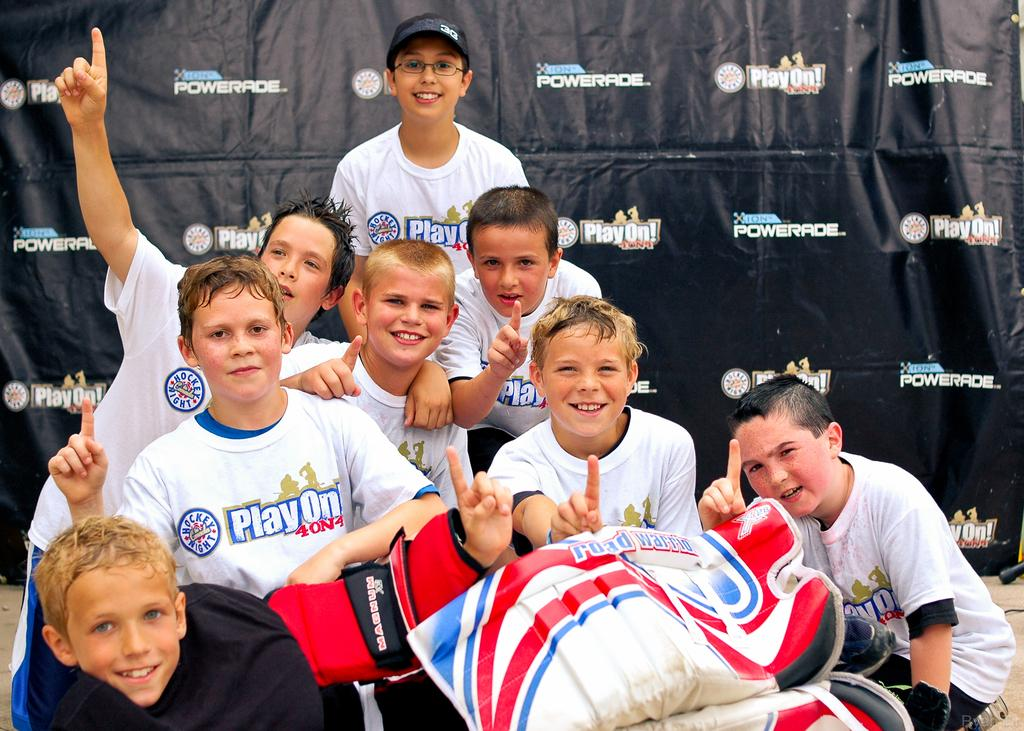<image>
Relay a brief, clear account of the picture shown. Kids wearing white shirts that say Play On 40N4. 